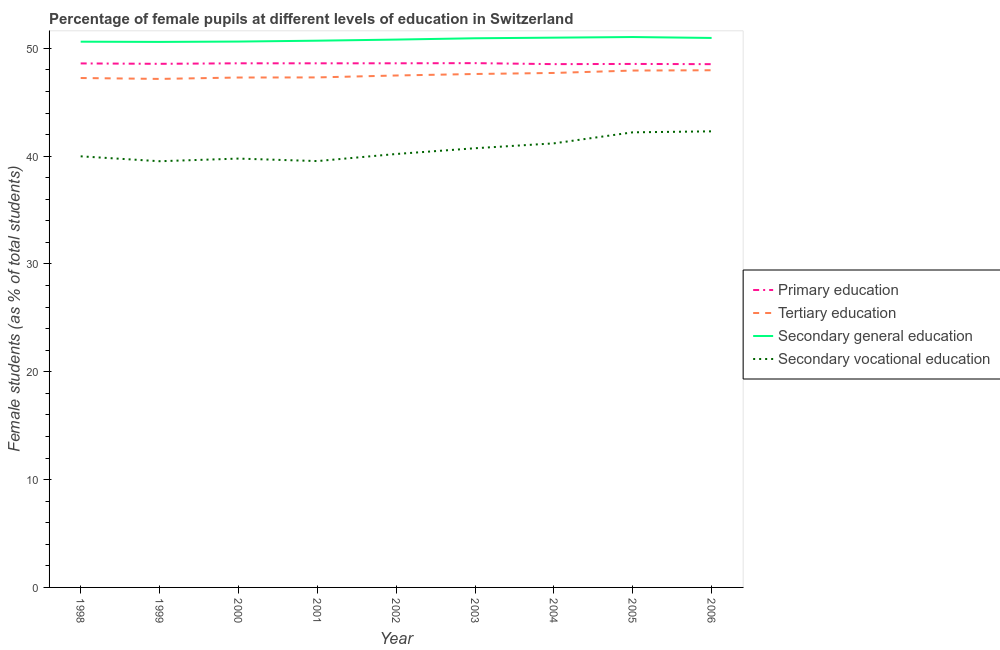What is the percentage of female students in tertiary education in 2006?
Offer a terse response. 47.97. Across all years, what is the maximum percentage of female students in secondary vocational education?
Make the answer very short. 42.31. Across all years, what is the minimum percentage of female students in primary education?
Ensure brevity in your answer.  48.54. In which year was the percentage of female students in tertiary education maximum?
Make the answer very short. 2006. In which year was the percentage of female students in primary education minimum?
Provide a short and direct response. 2006. What is the total percentage of female students in secondary education in the graph?
Keep it short and to the point. 457.34. What is the difference between the percentage of female students in primary education in 1999 and that in 2004?
Provide a short and direct response. 0.03. What is the difference between the percentage of female students in secondary education in 2002 and the percentage of female students in secondary vocational education in 2003?
Provide a short and direct response. 10.08. What is the average percentage of female students in primary education per year?
Offer a terse response. 48.59. In the year 1998, what is the difference between the percentage of female students in secondary education and percentage of female students in tertiary education?
Provide a succinct answer. 3.37. In how many years, is the percentage of female students in secondary vocational education greater than 44 %?
Your answer should be compact. 0. What is the ratio of the percentage of female students in tertiary education in 2001 to that in 2006?
Provide a short and direct response. 0.99. What is the difference between the highest and the second highest percentage of female students in tertiary education?
Keep it short and to the point. 0.03. What is the difference between the highest and the lowest percentage of female students in secondary vocational education?
Provide a short and direct response. 2.77. In how many years, is the percentage of female students in secondary vocational education greater than the average percentage of female students in secondary vocational education taken over all years?
Provide a short and direct response. 4. Is the sum of the percentage of female students in tertiary education in 1998 and 2003 greater than the maximum percentage of female students in secondary vocational education across all years?
Provide a short and direct response. Yes. Is it the case that in every year, the sum of the percentage of female students in primary education and percentage of female students in tertiary education is greater than the sum of percentage of female students in secondary vocational education and percentage of female students in secondary education?
Provide a short and direct response. Yes. Is it the case that in every year, the sum of the percentage of female students in primary education and percentage of female students in tertiary education is greater than the percentage of female students in secondary education?
Provide a short and direct response. Yes. Does the percentage of female students in tertiary education monotonically increase over the years?
Ensure brevity in your answer.  No. Is the percentage of female students in tertiary education strictly less than the percentage of female students in primary education over the years?
Give a very brief answer. Yes. How many lines are there?
Provide a succinct answer. 4. How many years are there in the graph?
Give a very brief answer. 9. Where does the legend appear in the graph?
Your answer should be very brief. Center right. How many legend labels are there?
Your answer should be very brief. 4. What is the title of the graph?
Your answer should be compact. Percentage of female pupils at different levels of education in Switzerland. Does "Japan" appear as one of the legend labels in the graph?
Ensure brevity in your answer.  No. What is the label or title of the Y-axis?
Offer a terse response. Female students (as % of total students). What is the Female students (as % of total students) in Primary education in 1998?
Provide a succinct answer. 48.6. What is the Female students (as % of total students) in Tertiary education in 1998?
Give a very brief answer. 47.25. What is the Female students (as % of total students) of Secondary general education in 1998?
Keep it short and to the point. 50.62. What is the Female students (as % of total students) in Secondary vocational education in 1998?
Provide a succinct answer. 39.99. What is the Female students (as % of total students) of Primary education in 1999?
Offer a terse response. 48.57. What is the Female students (as % of total students) of Tertiary education in 1999?
Offer a very short reply. 47.17. What is the Female students (as % of total students) of Secondary general education in 1999?
Your response must be concise. 50.6. What is the Female students (as % of total students) of Secondary vocational education in 1999?
Provide a short and direct response. 39.53. What is the Female students (as % of total students) of Primary education in 2000?
Give a very brief answer. 48.62. What is the Female students (as % of total students) of Tertiary education in 2000?
Offer a terse response. 47.3. What is the Female students (as % of total students) in Secondary general education in 2000?
Your answer should be compact. 50.63. What is the Female students (as % of total students) in Secondary vocational education in 2000?
Your response must be concise. 39.78. What is the Female students (as % of total students) of Primary education in 2001?
Your response must be concise. 48.61. What is the Female students (as % of total students) of Tertiary education in 2001?
Your answer should be compact. 47.31. What is the Female students (as % of total students) of Secondary general education in 2001?
Make the answer very short. 50.71. What is the Female students (as % of total students) in Secondary vocational education in 2001?
Your response must be concise. 39.55. What is the Female students (as % of total students) in Primary education in 2002?
Provide a short and direct response. 48.62. What is the Female students (as % of total students) in Tertiary education in 2002?
Offer a very short reply. 47.49. What is the Female students (as % of total students) of Secondary general education in 2002?
Make the answer very short. 50.82. What is the Female students (as % of total students) in Secondary vocational education in 2002?
Your answer should be very brief. 40.2. What is the Female students (as % of total students) of Primary education in 2003?
Offer a very short reply. 48.63. What is the Female students (as % of total students) in Tertiary education in 2003?
Your answer should be very brief. 47.62. What is the Female students (as % of total students) of Secondary general education in 2003?
Your answer should be compact. 50.94. What is the Female students (as % of total students) of Secondary vocational education in 2003?
Offer a very short reply. 40.74. What is the Female students (as % of total students) of Primary education in 2004?
Offer a very short reply. 48.54. What is the Female students (as % of total students) in Tertiary education in 2004?
Keep it short and to the point. 47.72. What is the Female students (as % of total students) of Secondary general education in 2004?
Offer a terse response. 50.99. What is the Female students (as % of total students) of Secondary vocational education in 2004?
Make the answer very short. 41.19. What is the Female students (as % of total students) of Primary education in 2005?
Offer a terse response. 48.56. What is the Female students (as % of total students) in Tertiary education in 2005?
Your answer should be very brief. 47.94. What is the Female students (as % of total students) of Secondary general education in 2005?
Make the answer very short. 51.05. What is the Female students (as % of total students) in Secondary vocational education in 2005?
Offer a very short reply. 42.21. What is the Female students (as % of total students) of Primary education in 2006?
Provide a succinct answer. 48.54. What is the Female students (as % of total students) in Tertiary education in 2006?
Your answer should be very brief. 47.97. What is the Female students (as % of total students) in Secondary general education in 2006?
Provide a short and direct response. 50.97. What is the Female students (as % of total students) of Secondary vocational education in 2006?
Provide a short and direct response. 42.31. Across all years, what is the maximum Female students (as % of total students) of Primary education?
Make the answer very short. 48.63. Across all years, what is the maximum Female students (as % of total students) in Tertiary education?
Offer a terse response. 47.97. Across all years, what is the maximum Female students (as % of total students) of Secondary general education?
Offer a very short reply. 51.05. Across all years, what is the maximum Female students (as % of total students) in Secondary vocational education?
Your answer should be very brief. 42.31. Across all years, what is the minimum Female students (as % of total students) in Primary education?
Your answer should be very brief. 48.54. Across all years, what is the minimum Female students (as % of total students) of Tertiary education?
Offer a very short reply. 47.17. Across all years, what is the minimum Female students (as % of total students) in Secondary general education?
Provide a succinct answer. 50.6. Across all years, what is the minimum Female students (as % of total students) in Secondary vocational education?
Your response must be concise. 39.53. What is the total Female students (as % of total students) in Primary education in the graph?
Keep it short and to the point. 437.28. What is the total Female students (as % of total students) of Tertiary education in the graph?
Offer a terse response. 427.77. What is the total Female students (as % of total students) in Secondary general education in the graph?
Offer a terse response. 457.34. What is the total Female students (as % of total students) in Secondary vocational education in the graph?
Your response must be concise. 365.5. What is the difference between the Female students (as % of total students) of Primary education in 1998 and that in 1999?
Make the answer very short. 0.04. What is the difference between the Female students (as % of total students) of Tertiary education in 1998 and that in 1999?
Your answer should be compact. 0.08. What is the difference between the Female students (as % of total students) of Secondary general education in 1998 and that in 1999?
Your response must be concise. 0.02. What is the difference between the Female students (as % of total students) of Secondary vocational education in 1998 and that in 1999?
Your answer should be compact. 0.46. What is the difference between the Female students (as % of total students) in Primary education in 1998 and that in 2000?
Your answer should be very brief. -0.01. What is the difference between the Female students (as % of total students) in Tertiary education in 1998 and that in 2000?
Provide a short and direct response. -0.05. What is the difference between the Female students (as % of total students) in Secondary general education in 1998 and that in 2000?
Offer a terse response. -0.01. What is the difference between the Female students (as % of total students) in Secondary vocational education in 1998 and that in 2000?
Your response must be concise. 0.21. What is the difference between the Female students (as % of total students) in Primary education in 1998 and that in 2001?
Keep it short and to the point. -0.01. What is the difference between the Female students (as % of total students) of Tertiary education in 1998 and that in 2001?
Offer a terse response. -0.06. What is the difference between the Female students (as % of total students) in Secondary general education in 1998 and that in 2001?
Keep it short and to the point. -0.09. What is the difference between the Female students (as % of total students) of Secondary vocational education in 1998 and that in 2001?
Provide a succinct answer. 0.44. What is the difference between the Female students (as % of total students) in Primary education in 1998 and that in 2002?
Provide a short and direct response. -0.01. What is the difference between the Female students (as % of total students) in Tertiary education in 1998 and that in 2002?
Make the answer very short. -0.23. What is the difference between the Female students (as % of total students) of Secondary general education in 1998 and that in 2002?
Your response must be concise. -0.19. What is the difference between the Female students (as % of total students) in Secondary vocational education in 1998 and that in 2002?
Your answer should be compact. -0.22. What is the difference between the Female students (as % of total students) in Primary education in 1998 and that in 2003?
Give a very brief answer. -0.03. What is the difference between the Female students (as % of total students) in Tertiary education in 1998 and that in 2003?
Make the answer very short. -0.37. What is the difference between the Female students (as % of total students) in Secondary general education in 1998 and that in 2003?
Your response must be concise. -0.32. What is the difference between the Female students (as % of total students) of Secondary vocational education in 1998 and that in 2003?
Give a very brief answer. -0.75. What is the difference between the Female students (as % of total students) of Primary education in 1998 and that in 2004?
Provide a succinct answer. 0.07. What is the difference between the Female students (as % of total students) of Tertiary education in 1998 and that in 2004?
Your answer should be compact. -0.47. What is the difference between the Female students (as % of total students) of Secondary general education in 1998 and that in 2004?
Give a very brief answer. -0.37. What is the difference between the Female students (as % of total students) in Secondary vocational education in 1998 and that in 2004?
Offer a very short reply. -1.2. What is the difference between the Female students (as % of total students) in Primary education in 1998 and that in 2005?
Your answer should be compact. 0.05. What is the difference between the Female students (as % of total students) in Tertiary education in 1998 and that in 2005?
Provide a short and direct response. -0.69. What is the difference between the Female students (as % of total students) in Secondary general education in 1998 and that in 2005?
Your answer should be compact. -0.43. What is the difference between the Female students (as % of total students) in Secondary vocational education in 1998 and that in 2005?
Provide a short and direct response. -2.23. What is the difference between the Female students (as % of total students) of Primary education in 1998 and that in 2006?
Make the answer very short. 0.07. What is the difference between the Female students (as % of total students) of Tertiary education in 1998 and that in 2006?
Your answer should be compact. -0.72. What is the difference between the Female students (as % of total students) in Secondary general education in 1998 and that in 2006?
Make the answer very short. -0.35. What is the difference between the Female students (as % of total students) of Secondary vocational education in 1998 and that in 2006?
Offer a terse response. -2.32. What is the difference between the Female students (as % of total students) of Primary education in 1999 and that in 2000?
Your response must be concise. -0.05. What is the difference between the Female students (as % of total students) in Tertiary education in 1999 and that in 2000?
Give a very brief answer. -0.13. What is the difference between the Female students (as % of total students) in Secondary general education in 1999 and that in 2000?
Provide a succinct answer. -0.03. What is the difference between the Female students (as % of total students) of Secondary vocational education in 1999 and that in 2000?
Ensure brevity in your answer.  -0.25. What is the difference between the Female students (as % of total students) of Primary education in 1999 and that in 2001?
Your answer should be very brief. -0.05. What is the difference between the Female students (as % of total students) in Tertiary education in 1999 and that in 2001?
Offer a terse response. -0.14. What is the difference between the Female students (as % of total students) of Secondary general education in 1999 and that in 2001?
Your answer should be very brief. -0.11. What is the difference between the Female students (as % of total students) of Secondary vocational education in 1999 and that in 2001?
Provide a short and direct response. -0.01. What is the difference between the Female students (as % of total students) in Primary education in 1999 and that in 2002?
Give a very brief answer. -0.05. What is the difference between the Female students (as % of total students) of Tertiary education in 1999 and that in 2002?
Your answer should be compact. -0.32. What is the difference between the Female students (as % of total students) of Secondary general education in 1999 and that in 2002?
Provide a succinct answer. -0.22. What is the difference between the Female students (as % of total students) of Secondary vocational education in 1999 and that in 2002?
Provide a succinct answer. -0.67. What is the difference between the Female students (as % of total students) in Primary education in 1999 and that in 2003?
Keep it short and to the point. -0.06. What is the difference between the Female students (as % of total students) of Tertiary education in 1999 and that in 2003?
Offer a terse response. -0.46. What is the difference between the Female students (as % of total students) of Secondary general education in 1999 and that in 2003?
Provide a succinct answer. -0.34. What is the difference between the Female students (as % of total students) of Secondary vocational education in 1999 and that in 2003?
Your answer should be compact. -1.2. What is the difference between the Female students (as % of total students) in Primary education in 1999 and that in 2004?
Your answer should be very brief. 0.03. What is the difference between the Female students (as % of total students) in Tertiary education in 1999 and that in 2004?
Ensure brevity in your answer.  -0.55. What is the difference between the Female students (as % of total students) in Secondary general education in 1999 and that in 2004?
Your answer should be very brief. -0.39. What is the difference between the Female students (as % of total students) in Secondary vocational education in 1999 and that in 2004?
Provide a succinct answer. -1.66. What is the difference between the Female students (as % of total students) in Primary education in 1999 and that in 2005?
Make the answer very short. 0.01. What is the difference between the Female students (as % of total students) in Tertiary education in 1999 and that in 2005?
Offer a terse response. -0.78. What is the difference between the Female students (as % of total students) in Secondary general education in 1999 and that in 2005?
Offer a terse response. -0.45. What is the difference between the Female students (as % of total students) of Secondary vocational education in 1999 and that in 2005?
Offer a terse response. -2.68. What is the difference between the Female students (as % of total students) in Primary education in 1999 and that in 2006?
Your answer should be very brief. 0.03. What is the difference between the Female students (as % of total students) in Tertiary education in 1999 and that in 2006?
Your response must be concise. -0.8. What is the difference between the Female students (as % of total students) in Secondary general education in 1999 and that in 2006?
Your answer should be very brief. -0.37. What is the difference between the Female students (as % of total students) of Secondary vocational education in 1999 and that in 2006?
Provide a succinct answer. -2.77. What is the difference between the Female students (as % of total students) in Primary education in 2000 and that in 2001?
Your answer should be very brief. 0. What is the difference between the Female students (as % of total students) of Tertiary education in 2000 and that in 2001?
Make the answer very short. -0.01. What is the difference between the Female students (as % of total students) of Secondary general education in 2000 and that in 2001?
Give a very brief answer. -0.08. What is the difference between the Female students (as % of total students) of Secondary vocational education in 2000 and that in 2001?
Provide a short and direct response. 0.23. What is the difference between the Female students (as % of total students) in Primary education in 2000 and that in 2002?
Your answer should be very brief. -0. What is the difference between the Female students (as % of total students) of Tertiary education in 2000 and that in 2002?
Your answer should be compact. -0.19. What is the difference between the Female students (as % of total students) of Secondary general education in 2000 and that in 2002?
Provide a succinct answer. -0.18. What is the difference between the Female students (as % of total students) of Secondary vocational education in 2000 and that in 2002?
Offer a very short reply. -0.43. What is the difference between the Female students (as % of total students) in Primary education in 2000 and that in 2003?
Make the answer very short. -0.02. What is the difference between the Female students (as % of total students) in Tertiary education in 2000 and that in 2003?
Offer a very short reply. -0.33. What is the difference between the Female students (as % of total students) of Secondary general education in 2000 and that in 2003?
Give a very brief answer. -0.3. What is the difference between the Female students (as % of total students) of Secondary vocational education in 2000 and that in 2003?
Your response must be concise. -0.96. What is the difference between the Female students (as % of total students) in Primary education in 2000 and that in 2004?
Make the answer very short. 0.08. What is the difference between the Female students (as % of total students) in Tertiary education in 2000 and that in 2004?
Offer a terse response. -0.42. What is the difference between the Female students (as % of total students) in Secondary general education in 2000 and that in 2004?
Make the answer very short. -0.36. What is the difference between the Female students (as % of total students) of Secondary vocational education in 2000 and that in 2004?
Keep it short and to the point. -1.41. What is the difference between the Female students (as % of total students) of Primary education in 2000 and that in 2005?
Your response must be concise. 0.06. What is the difference between the Female students (as % of total students) of Tertiary education in 2000 and that in 2005?
Provide a succinct answer. -0.65. What is the difference between the Female students (as % of total students) of Secondary general education in 2000 and that in 2005?
Offer a terse response. -0.42. What is the difference between the Female students (as % of total students) of Secondary vocational education in 2000 and that in 2005?
Your answer should be compact. -2.44. What is the difference between the Female students (as % of total students) of Primary education in 2000 and that in 2006?
Your answer should be compact. 0.08. What is the difference between the Female students (as % of total students) in Tertiary education in 2000 and that in 2006?
Keep it short and to the point. -0.67. What is the difference between the Female students (as % of total students) of Secondary general education in 2000 and that in 2006?
Your response must be concise. -0.33. What is the difference between the Female students (as % of total students) in Secondary vocational education in 2000 and that in 2006?
Make the answer very short. -2.53. What is the difference between the Female students (as % of total students) of Primary education in 2001 and that in 2002?
Your response must be concise. -0. What is the difference between the Female students (as % of total students) of Tertiary education in 2001 and that in 2002?
Keep it short and to the point. -0.18. What is the difference between the Female students (as % of total students) of Secondary general education in 2001 and that in 2002?
Offer a very short reply. -0.1. What is the difference between the Female students (as % of total students) in Secondary vocational education in 2001 and that in 2002?
Keep it short and to the point. -0.66. What is the difference between the Female students (as % of total students) of Primary education in 2001 and that in 2003?
Your answer should be compact. -0.02. What is the difference between the Female students (as % of total students) in Tertiary education in 2001 and that in 2003?
Provide a succinct answer. -0.32. What is the difference between the Female students (as % of total students) of Secondary general education in 2001 and that in 2003?
Provide a succinct answer. -0.22. What is the difference between the Female students (as % of total students) in Secondary vocational education in 2001 and that in 2003?
Your answer should be compact. -1.19. What is the difference between the Female students (as % of total students) in Primary education in 2001 and that in 2004?
Give a very brief answer. 0.08. What is the difference between the Female students (as % of total students) in Tertiary education in 2001 and that in 2004?
Offer a very short reply. -0.41. What is the difference between the Female students (as % of total students) of Secondary general education in 2001 and that in 2004?
Provide a short and direct response. -0.28. What is the difference between the Female students (as % of total students) of Secondary vocational education in 2001 and that in 2004?
Your answer should be very brief. -1.64. What is the difference between the Female students (as % of total students) in Primary education in 2001 and that in 2005?
Your response must be concise. 0.06. What is the difference between the Female students (as % of total students) of Tertiary education in 2001 and that in 2005?
Provide a short and direct response. -0.64. What is the difference between the Female students (as % of total students) of Secondary general education in 2001 and that in 2005?
Give a very brief answer. -0.34. What is the difference between the Female students (as % of total students) in Secondary vocational education in 2001 and that in 2005?
Offer a terse response. -2.67. What is the difference between the Female students (as % of total students) of Primary education in 2001 and that in 2006?
Offer a very short reply. 0.08. What is the difference between the Female students (as % of total students) in Tertiary education in 2001 and that in 2006?
Provide a succinct answer. -0.66. What is the difference between the Female students (as % of total students) of Secondary general education in 2001 and that in 2006?
Provide a short and direct response. -0.25. What is the difference between the Female students (as % of total students) of Secondary vocational education in 2001 and that in 2006?
Your response must be concise. -2.76. What is the difference between the Female students (as % of total students) in Primary education in 2002 and that in 2003?
Your answer should be very brief. -0.01. What is the difference between the Female students (as % of total students) in Tertiary education in 2002 and that in 2003?
Offer a very short reply. -0.14. What is the difference between the Female students (as % of total students) in Secondary general education in 2002 and that in 2003?
Give a very brief answer. -0.12. What is the difference between the Female students (as % of total students) of Secondary vocational education in 2002 and that in 2003?
Provide a short and direct response. -0.53. What is the difference between the Female students (as % of total students) of Primary education in 2002 and that in 2004?
Your answer should be compact. 0.08. What is the difference between the Female students (as % of total students) in Tertiary education in 2002 and that in 2004?
Your response must be concise. -0.24. What is the difference between the Female students (as % of total students) of Secondary general education in 2002 and that in 2004?
Provide a short and direct response. -0.18. What is the difference between the Female students (as % of total students) in Secondary vocational education in 2002 and that in 2004?
Provide a short and direct response. -0.99. What is the difference between the Female students (as % of total students) of Primary education in 2002 and that in 2005?
Ensure brevity in your answer.  0.06. What is the difference between the Female students (as % of total students) of Tertiary education in 2002 and that in 2005?
Your answer should be compact. -0.46. What is the difference between the Female students (as % of total students) of Secondary general education in 2002 and that in 2005?
Offer a terse response. -0.24. What is the difference between the Female students (as % of total students) in Secondary vocational education in 2002 and that in 2005?
Ensure brevity in your answer.  -2.01. What is the difference between the Female students (as % of total students) of Primary education in 2002 and that in 2006?
Keep it short and to the point. 0.08. What is the difference between the Female students (as % of total students) in Tertiary education in 2002 and that in 2006?
Keep it short and to the point. -0.49. What is the difference between the Female students (as % of total students) in Secondary general education in 2002 and that in 2006?
Make the answer very short. -0.15. What is the difference between the Female students (as % of total students) in Secondary vocational education in 2002 and that in 2006?
Ensure brevity in your answer.  -2.1. What is the difference between the Female students (as % of total students) of Primary education in 2003 and that in 2004?
Your response must be concise. 0.09. What is the difference between the Female students (as % of total students) in Tertiary education in 2003 and that in 2004?
Your answer should be compact. -0.1. What is the difference between the Female students (as % of total students) in Secondary general education in 2003 and that in 2004?
Give a very brief answer. -0.06. What is the difference between the Female students (as % of total students) in Secondary vocational education in 2003 and that in 2004?
Your response must be concise. -0.45. What is the difference between the Female students (as % of total students) in Primary education in 2003 and that in 2005?
Your answer should be very brief. 0.07. What is the difference between the Female students (as % of total students) in Tertiary education in 2003 and that in 2005?
Your answer should be compact. -0.32. What is the difference between the Female students (as % of total students) of Secondary general education in 2003 and that in 2005?
Offer a terse response. -0.11. What is the difference between the Female students (as % of total students) of Secondary vocational education in 2003 and that in 2005?
Your answer should be very brief. -1.48. What is the difference between the Female students (as % of total students) of Primary education in 2003 and that in 2006?
Ensure brevity in your answer.  0.09. What is the difference between the Female students (as % of total students) of Tertiary education in 2003 and that in 2006?
Give a very brief answer. -0.35. What is the difference between the Female students (as % of total students) in Secondary general education in 2003 and that in 2006?
Offer a terse response. -0.03. What is the difference between the Female students (as % of total students) of Secondary vocational education in 2003 and that in 2006?
Offer a very short reply. -1.57. What is the difference between the Female students (as % of total students) in Primary education in 2004 and that in 2005?
Ensure brevity in your answer.  -0.02. What is the difference between the Female students (as % of total students) in Tertiary education in 2004 and that in 2005?
Offer a very short reply. -0.22. What is the difference between the Female students (as % of total students) of Secondary general education in 2004 and that in 2005?
Make the answer very short. -0.06. What is the difference between the Female students (as % of total students) of Secondary vocational education in 2004 and that in 2005?
Your answer should be very brief. -1.02. What is the difference between the Female students (as % of total students) in Primary education in 2004 and that in 2006?
Provide a succinct answer. 0. What is the difference between the Female students (as % of total students) in Tertiary education in 2004 and that in 2006?
Your response must be concise. -0.25. What is the difference between the Female students (as % of total students) in Secondary general education in 2004 and that in 2006?
Provide a succinct answer. 0.03. What is the difference between the Female students (as % of total students) of Secondary vocational education in 2004 and that in 2006?
Your answer should be compact. -1.11. What is the difference between the Female students (as % of total students) of Primary education in 2005 and that in 2006?
Give a very brief answer. 0.02. What is the difference between the Female students (as % of total students) in Tertiary education in 2005 and that in 2006?
Ensure brevity in your answer.  -0.03. What is the difference between the Female students (as % of total students) in Secondary general education in 2005 and that in 2006?
Keep it short and to the point. 0.09. What is the difference between the Female students (as % of total students) in Secondary vocational education in 2005 and that in 2006?
Make the answer very short. -0.09. What is the difference between the Female students (as % of total students) of Primary education in 1998 and the Female students (as % of total students) of Tertiary education in 1999?
Your answer should be compact. 1.44. What is the difference between the Female students (as % of total students) of Primary education in 1998 and the Female students (as % of total students) of Secondary general education in 1999?
Offer a terse response. -2. What is the difference between the Female students (as % of total students) in Primary education in 1998 and the Female students (as % of total students) in Secondary vocational education in 1999?
Your answer should be very brief. 9.07. What is the difference between the Female students (as % of total students) in Tertiary education in 1998 and the Female students (as % of total students) in Secondary general education in 1999?
Your answer should be compact. -3.35. What is the difference between the Female students (as % of total students) of Tertiary education in 1998 and the Female students (as % of total students) of Secondary vocational education in 1999?
Offer a very short reply. 7.72. What is the difference between the Female students (as % of total students) of Secondary general education in 1998 and the Female students (as % of total students) of Secondary vocational education in 1999?
Your answer should be very brief. 11.09. What is the difference between the Female students (as % of total students) of Primary education in 1998 and the Female students (as % of total students) of Tertiary education in 2000?
Offer a very short reply. 1.31. What is the difference between the Female students (as % of total students) of Primary education in 1998 and the Female students (as % of total students) of Secondary general education in 2000?
Keep it short and to the point. -2.03. What is the difference between the Female students (as % of total students) of Primary education in 1998 and the Female students (as % of total students) of Secondary vocational education in 2000?
Provide a short and direct response. 8.83. What is the difference between the Female students (as % of total students) of Tertiary education in 1998 and the Female students (as % of total students) of Secondary general education in 2000?
Offer a very short reply. -3.38. What is the difference between the Female students (as % of total students) of Tertiary education in 1998 and the Female students (as % of total students) of Secondary vocational education in 2000?
Make the answer very short. 7.47. What is the difference between the Female students (as % of total students) of Secondary general education in 1998 and the Female students (as % of total students) of Secondary vocational education in 2000?
Offer a very short reply. 10.84. What is the difference between the Female students (as % of total students) in Primary education in 1998 and the Female students (as % of total students) in Tertiary education in 2001?
Give a very brief answer. 1.3. What is the difference between the Female students (as % of total students) in Primary education in 1998 and the Female students (as % of total students) in Secondary general education in 2001?
Keep it short and to the point. -2.11. What is the difference between the Female students (as % of total students) of Primary education in 1998 and the Female students (as % of total students) of Secondary vocational education in 2001?
Your response must be concise. 9.06. What is the difference between the Female students (as % of total students) in Tertiary education in 1998 and the Female students (as % of total students) in Secondary general education in 2001?
Provide a short and direct response. -3.46. What is the difference between the Female students (as % of total students) of Tertiary education in 1998 and the Female students (as % of total students) of Secondary vocational education in 2001?
Offer a very short reply. 7.71. What is the difference between the Female students (as % of total students) in Secondary general education in 1998 and the Female students (as % of total students) in Secondary vocational education in 2001?
Provide a succinct answer. 11.07. What is the difference between the Female students (as % of total students) of Primary education in 1998 and the Female students (as % of total students) of Tertiary education in 2002?
Provide a succinct answer. 1.12. What is the difference between the Female students (as % of total students) in Primary education in 1998 and the Female students (as % of total students) in Secondary general education in 2002?
Offer a terse response. -2.21. What is the difference between the Female students (as % of total students) in Primary education in 1998 and the Female students (as % of total students) in Secondary vocational education in 2002?
Provide a short and direct response. 8.4. What is the difference between the Female students (as % of total students) of Tertiary education in 1998 and the Female students (as % of total students) of Secondary general education in 2002?
Provide a short and direct response. -3.56. What is the difference between the Female students (as % of total students) in Tertiary education in 1998 and the Female students (as % of total students) in Secondary vocational education in 2002?
Offer a terse response. 7.05. What is the difference between the Female students (as % of total students) of Secondary general education in 1998 and the Female students (as % of total students) of Secondary vocational education in 2002?
Provide a succinct answer. 10.42. What is the difference between the Female students (as % of total students) in Primary education in 1998 and the Female students (as % of total students) in Tertiary education in 2003?
Your response must be concise. 0.98. What is the difference between the Female students (as % of total students) in Primary education in 1998 and the Female students (as % of total students) in Secondary general education in 2003?
Your response must be concise. -2.33. What is the difference between the Female students (as % of total students) in Primary education in 1998 and the Female students (as % of total students) in Secondary vocational education in 2003?
Ensure brevity in your answer.  7.87. What is the difference between the Female students (as % of total students) in Tertiary education in 1998 and the Female students (as % of total students) in Secondary general education in 2003?
Ensure brevity in your answer.  -3.69. What is the difference between the Female students (as % of total students) of Tertiary education in 1998 and the Female students (as % of total students) of Secondary vocational education in 2003?
Make the answer very short. 6.51. What is the difference between the Female students (as % of total students) of Secondary general education in 1998 and the Female students (as % of total students) of Secondary vocational education in 2003?
Make the answer very short. 9.88. What is the difference between the Female students (as % of total students) in Primary education in 1998 and the Female students (as % of total students) in Tertiary education in 2004?
Provide a succinct answer. 0.88. What is the difference between the Female students (as % of total students) of Primary education in 1998 and the Female students (as % of total students) of Secondary general education in 2004?
Your response must be concise. -2.39. What is the difference between the Female students (as % of total students) of Primary education in 1998 and the Female students (as % of total students) of Secondary vocational education in 2004?
Offer a terse response. 7.41. What is the difference between the Female students (as % of total students) in Tertiary education in 1998 and the Female students (as % of total students) in Secondary general education in 2004?
Your answer should be very brief. -3.74. What is the difference between the Female students (as % of total students) of Tertiary education in 1998 and the Female students (as % of total students) of Secondary vocational education in 2004?
Make the answer very short. 6.06. What is the difference between the Female students (as % of total students) in Secondary general education in 1998 and the Female students (as % of total students) in Secondary vocational education in 2004?
Provide a succinct answer. 9.43. What is the difference between the Female students (as % of total students) in Primary education in 1998 and the Female students (as % of total students) in Tertiary education in 2005?
Offer a terse response. 0.66. What is the difference between the Female students (as % of total students) in Primary education in 1998 and the Female students (as % of total students) in Secondary general education in 2005?
Ensure brevity in your answer.  -2.45. What is the difference between the Female students (as % of total students) of Primary education in 1998 and the Female students (as % of total students) of Secondary vocational education in 2005?
Give a very brief answer. 6.39. What is the difference between the Female students (as % of total students) in Tertiary education in 1998 and the Female students (as % of total students) in Secondary general education in 2005?
Your response must be concise. -3.8. What is the difference between the Female students (as % of total students) of Tertiary education in 1998 and the Female students (as % of total students) of Secondary vocational education in 2005?
Make the answer very short. 5.04. What is the difference between the Female students (as % of total students) of Secondary general education in 1998 and the Female students (as % of total students) of Secondary vocational education in 2005?
Offer a terse response. 8.41. What is the difference between the Female students (as % of total students) of Primary education in 1998 and the Female students (as % of total students) of Tertiary education in 2006?
Your response must be concise. 0.63. What is the difference between the Female students (as % of total students) of Primary education in 1998 and the Female students (as % of total students) of Secondary general education in 2006?
Make the answer very short. -2.36. What is the difference between the Female students (as % of total students) in Primary education in 1998 and the Female students (as % of total students) in Secondary vocational education in 2006?
Offer a terse response. 6.3. What is the difference between the Female students (as % of total students) of Tertiary education in 1998 and the Female students (as % of total students) of Secondary general education in 2006?
Your answer should be very brief. -3.72. What is the difference between the Female students (as % of total students) in Tertiary education in 1998 and the Female students (as % of total students) in Secondary vocational education in 2006?
Ensure brevity in your answer.  4.95. What is the difference between the Female students (as % of total students) of Secondary general education in 1998 and the Female students (as % of total students) of Secondary vocational education in 2006?
Ensure brevity in your answer.  8.32. What is the difference between the Female students (as % of total students) of Primary education in 1999 and the Female students (as % of total students) of Tertiary education in 2000?
Provide a succinct answer. 1.27. What is the difference between the Female students (as % of total students) of Primary education in 1999 and the Female students (as % of total students) of Secondary general education in 2000?
Your response must be concise. -2.06. What is the difference between the Female students (as % of total students) of Primary education in 1999 and the Female students (as % of total students) of Secondary vocational education in 2000?
Offer a terse response. 8.79. What is the difference between the Female students (as % of total students) in Tertiary education in 1999 and the Female students (as % of total students) in Secondary general education in 2000?
Your answer should be compact. -3.47. What is the difference between the Female students (as % of total students) of Tertiary education in 1999 and the Female students (as % of total students) of Secondary vocational education in 2000?
Ensure brevity in your answer.  7.39. What is the difference between the Female students (as % of total students) in Secondary general education in 1999 and the Female students (as % of total students) in Secondary vocational education in 2000?
Offer a terse response. 10.82. What is the difference between the Female students (as % of total students) of Primary education in 1999 and the Female students (as % of total students) of Tertiary education in 2001?
Give a very brief answer. 1.26. What is the difference between the Female students (as % of total students) in Primary education in 1999 and the Female students (as % of total students) in Secondary general education in 2001?
Offer a terse response. -2.15. What is the difference between the Female students (as % of total students) in Primary education in 1999 and the Female students (as % of total students) in Secondary vocational education in 2001?
Your answer should be compact. 9.02. What is the difference between the Female students (as % of total students) of Tertiary education in 1999 and the Female students (as % of total students) of Secondary general education in 2001?
Your answer should be very brief. -3.55. What is the difference between the Female students (as % of total students) of Tertiary education in 1999 and the Female students (as % of total students) of Secondary vocational education in 2001?
Provide a succinct answer. 7.62. What is the difference between the Female students (as % of total students) of Secondary general education in 1999 and the Female students (as % of total students) of Secondary vocational education in 2001?
Provide a succinct answer. 11.05. What is the difference between the Female students (as % of total students) in Primary education in 1999 and the Female students (as % of total students) in Tertiary education in 2002?
Give a very brief answer. 1.08. What is the difference between the Female students (as % of total students) in Primary education in 1999 and the Female students (as % of total students) in Secondary general education in 2002?
Keep it short and to the point. -2.25. What is the difference between the Female students (as % of total students) of Primary education in 1999 and the Female students (as % of total students) of Secondary vocational education in 2002?
Provide a short and direct response. 8.36. What is the difference between the Female students (as % of total students) of Tertiary education in 1999 and the Female students (as % of total students) of Secondary general education in 2002?
Your response must be concise. -3.65. What is the difference between the Female students (as % of total students) of Tertiary education in 1999 and the Female students (as % of total students) of Secondary vocational education in 2002?
Your response must be concise. 6.96. What is the difference between the Female students (as % of total students) of Secondary general education in 1999 and the Female students (as % of total students) of Secondary vocational education in 2002?
Ensure brevity in your answer.  10.4. What is the difference between the Female students (as % of total students) of Primary education in 1999 and the Female students (as % of total students) of Tertiary education in 2003?
Your answer should be very brief. 0.94. What is the difference between the Female students (as % of total students) in Primary education in 1999 and the Female students (as % of total students) in Secondary general education in 2003?
Give a very brief answer. -2.37. What is the difference between the Female students (as % of total students) in Primary education in 1999 and the Female students (as % of total students) in Secondary vocational education in 2003?
Your answer should be compact. 7.83. What is the difference between the Female students (as % of total students) in Tertiary education in 1999 and the Female students (as % of total students) in Secondary general education in 2003?
Your answer should be compact. -3.77. What is the difference between the Female students (as % of total students) of Tertiary education in 1999 and the Female students (as % of total students) of Secondary vocational education in 2003?
Ensure brevity in your answer.  6.43. What is the difference between the Female students (as % of total students) of Secondary general education in 1999 and the Female students (as % of total students) of Secondary vocational education in 2003?
Your answer should be very brief. 9.86. What is the difference between the Female students (as % of total students) in Primary education in 1999 and the Female students (as % of total students) in Tertiary education in 2004?
Give a very brief answer. 0.85. What is the difference between the Female students (as % of total students) in Primary education in 1999 and the Female students (as % of total students) in Secondary general education in 2004?
Your answer should be very brief. -2.43. What is the difference between the Female students (as % of total students) in Primary education in 1999 and the Female students (as % of total students) in Secondary vocational education in 2004?
Make the answer very short. 7.38. What is the difference between the Female students (as % of total students) in Tertiary education in 1999 and the Female students (as % of total students) in Secondary general education in 2004?
Provide a short and direct response. -3.83. What is the difference between the Female students (as % of total students) in Tertiary education in 1999 and the Female students (as % of total students) in Secondary vocational education in 2004?
Your answer should be compact. 5.98. What is the difference between the Female students (as % of total students) in Secondary general education in 1999 and the Female students (as % of total students) in Secondary vocational education in 2004?
Ensure brevity in your answer.  9.41. What is the difference between the Female students (as % of total students) in Primary education in 1999 and the Female students (as % of total students) in Tertiary education in 2005?
Offer a very short reply. 0.62. What is the difference between the Female students (as % of total students) of Primary education in 1999 and the Female students (as % of total students) of Secondary general education in 2005?
Your response must be concise. -2.48. What is the difference between the Female students (as % of total students) in Primary education in 1999 and the Female students (as % of total students) in Secondary vocational education in 2005?
Offer a terse response. 6.35. What is the difference between the Female students (as % of total students) in Tertiary education in 1999 and the Female students (as % of total students) in Secondary general education in 2005?
Provide a short and direct response. -3.88. What is the difference between the Female students (as % of total students) of Tertiary education in 1999 and the Female students (as % of total students) of Secondary vocational education in 2005?
Your answer should be very brief. 4.95. What is the difference between the Female students (as % of total students) of Secondary general education in 1999 and the Female students (as % of total students) of Secondary vocational education in 2005?
Provide a succinct answer. 8.39. What is the difference between the Female students (as % of total students) of Primary education in 1999 and the Female students (as % of total students) of Tertiary education in 2006?
Ensure brevity in your answer.  0.6. What is the difference between the Female students (as % of total students) of Primary education in 1999 and the Female students (as % of total students) of Secondary general education in 2006?
Keep it short and to the point. -2.4. What is the difference between the Female students (as % of total students) of Primary education in 1999 and the Female students (as % of total students) of Secondary vocational education in 2006?
Give a very brief answer. 6.26. What is the difference between the Female students (as % of total students) of Tertiary education in 1999 and the Female students (as % of total students) of Secondary general education in 2006?
Provide a succinct answer. -3.8. What is the difference between the Female students (as % of total students) in Tertiary education in 1999 and the Female students (as % of total students) in Secondary vocational education in 2006?
Make the answer very short. 4.86. What is the difference between the Female students (as % of total students) in Secondary general education in 1999 and the Female students (as % of total students) in Secondary vocational education in 2006?
Your answer should be compact. 8.3. What is the difference between the Female students (as % of total students) of Primary education in 2000 and the Female students (as % of total students) of Tertiary education in 2001?
Make the answer very short. 1.31. What is the difference between the Female students (as % of total students) in Primary education in 2000 and the Female students (as % of total students) in Secondary general education in 2001?
Provide a short and direct response. -2.1. What is the difference between the Female students (as % of total students) in Primary education in 2000 and the Female students (as % of total students) in Secondary vocational education in 2001?
Offer a very short reply. 9.07. What is the difference between the Female students (as % of total students) in Tertiary education in 2000 and the Female students (as % of total students) in Secondary general education in 2001?
Keep it short and to the point. -3.42. What is the difference between the Female students (as % of total students) in Tertiary education in 2000 and the Female students (as % of total students) in Secondary vocational education in 2001?
Provide a succinct answer. 7.75. What is the difference between the Female students (as % of total students) of Secondary general education in 2000 and the Female students (as % of total students) of Secondary vocational education in 2001?
Your response must be concise. 11.09. What is the difference between the Female students (as % of total students) in Primary education in 2000 and the Female students (as % of total students) in Tertiary education in 2002?
Offer a very short reply. 1.13. What is the difference between the Female students (as % of total students) in Primary education in 2000 and the Female students (as % of total students) in Secondary vocational education in 2002?
Provide a short and direct response. 8.41. What is the difference between the Female students (as % of total students) of Tertiary education in 2000 and the Female students (as % of total students) of Secondary general education in 2002?
Provide a succinct answer. -3.52. What is the difference between the Female students (as % of total students) of Tertiary education in 2000 and the Female students (as % of total students) of Secondary vocational education in 2002?
Make the answer very short. 7.09. What is the difference between the Female students (as % of total students) of Secondary general education in 2000 and the Female students (as % of total students) of Secondary vocational education in 2002?
Give a very brief answer. 10.43. What is the difference between the Female students (as % of total students) of Primary education in 2000 and the Female students (as % of total students) of Tertiary education in 2003?
Your answer should be compact. 0.99. What is the difference between the Female students (as % of total students) of Primary education in 2000 and the Female students (as % of total students) of Secondary general education in 2003?
Ensure brevity in your answer.  -2.32. What is the difference between the Female students (as % of total students) in Primary education in 2000 and the Female students (as % of total students) in Secondary vocational education in 2003?
Provide a succinct answer. 7.88. What is the difference between the Female students (as % of total students) in Tertiary education in 2000 and the Female students (as % of total students) in Secondary general education in 2003?
Ensure brevity in your answer.  -3.64. What is the difference between the Female students (as % of total students) in Tertiary education in 2000 and the Female students (as % of total students) in Secondary vocational education in 2003?
Keep it short and to the point. 6.56. What is the difference between the Female students (as % of total students) of Secondary general education in 2000 and the Female students (as % of total students) of Secondary vocational education in 2003?
Offer a very short reply. 9.9. What is the difference between the Female students (as % of total students) of Primary education in 2000 and the Female students (as % of total students) of Tertiary education in 2004?
Your answer should be very brief. 0.9. What is the difference between the Female students (as % of total students) of Primary education in 2000 and the Female students (as % of total students) of Secondary general education in 2004?
Provide a short and direct response. -2.38. What is the difference between the Female students (as % of total students) in Primary education in 2000 and the Female students (as % of total students) in Secondary vocational education in 2004?
Make the answer very short. 7.42. What is the difference between the Female students (as % of total students) of Tertiary education in 2000 and the Female students (as % of total students) of Secondary general education in 2004?
Ensure brevity in your answer.  -3.7. What is the difference between the Female students (as % of total students) of Tertiary education in 2000 and the Female students (as % of total students) of Secondary vocational education in 2004?
Make the answer very short. 6.11. What is the difference between the Female students (as % of total students) of Secondary general education in 2000 and the Female students (as % of total students) of Secondary vocational education in 2004?
Provide a short and direct response. 9.44. What is the difference between the Female students (as % of total students) in Primary education in 2000 and the Female students (as % of total students) in Tertiary education in 2005?
Your response must be concise. 0.67. What is the difference between the Female students (as % of total students) of Primary education in 2000 and the Female students (as % of total students) of Secondary general education in 2005?
Your answer should be very brief. -2.44. What is the difference between the Female students (as % of total students) of Primary education in 2000 and the Female students (as % of total students) of Secondary vocational education in 2005?
Give a very brief answer. 6.4. What is the difference between the Female students (as % of total students) of Tertiary education in 2000 and the Female students (as % of total students) of Secondary general education in 2005?
Your answer should be compact. -3.75. What is the difference between the Female students (as % of total students) of Tertiary education in 2000 and the Female students (as % of total students) of Secondary vocational education in 2005?
Provide a succinct answer. 5.08. What is the difference between the Female students (as % of total students) of Secondary general education in 2000 and the Female students (as % of total students) of Secondary vocational education in 2005?
Provide a succinct answer. 8.42. What is the difference between the Female students (as % of total students) in Primary education in 2000 and the Female students (as % of total students) in Tertiary education in 2006?
Keep it short and to the point. 0.64. What is the difference between the Female students (as % of total students) in Primary education in 2000 and the Female students (as % of total students) in Secondary general education in 2006?
Your response must be concise. -2.35. What is the difference between the Female students (as % of total students) in Primary education in 2000 and the Female students (as % of total students) in Secondary vocational education in 2006?
Your answer should be very brief. 6.31. What is the difference between the Female students (as % of total students) in Tertiary education in 2000 and the Female students (as % of total students) in Secondary general education in 2006?
Keep it short and to the point. -3.67. What is the difference between the Female students (as % of total students) of Tertiary education in 2000 and the Female students (as % of total students) of Secondary vocational education in 2006?
Offer a very short reply. 4.99. What is the difference between the Female students (as % of total students) in Secondary general education in 2000 and the Female students (as % of total students) in Secondary vocational education in 2006?
Make the answer very short. 8.33. What is the difference between the Female students (as % of total students) in Primary education in 2001 and the Female students (as % of total students) in Tertiary education in 2002?
Ensure brevity in your answer.  1.13. What is the difference between the Female students (as % of total students) of Primary education in 2001 and the Female students (as % of total students) of Secondary general education in 2002?
Provide a succinct answer. -2.2. What is the difference between the Female students (as % of total students) of Primary education in 2001 and the Female students (as % of total students) of Secondary vocational education in 2002?
Your answer should be compact. 8.41. What is the difference between the Female students (as % of total students) of Tertiary education in 2001 and the Female students (as % of total students) of Secondary general education in 2002?
Ensure brevity in your answer.  -3.51. What is the difference between the Female students (as % of total students) of Tertiary education in 2001 and the Female students (as % of total students) of Secondary vocational education in 2002?
Keep it short and to the point. 7.1. What is the difference between the Female students (as % of total students) in Secondary general education in 2001 and the Female students (as % of total students) in Secondary vocational education in 2002?
Your answer should be very brief. 10.51. What is the difference between the Female students (as % of total students) of Primary education in 2001 and the Female students (as % of total students) of Tertiary education in 2003?
Keep it short and to the point. 0.99. What is the difference between the Female students (as % of total students) of Primary education in 2001 and the Female students (as % of total students) of Secondary general education in 2003?
Your answer should be very brief. -2.32. What is the difference between the Female students (as % of total students) of Primary education in 2001 and the Female students (as % of total students) of Secondary vocational education in 2003?
Make the answer very short. 7.88. What is the difference between the Female students (as % of total students) in Tertiary education in 2001 and the Female students (as % of total students) in Secondary general education in 2003?
Your response must be concise. -3.63. What is the difference between the Female students (as % of total students) in Tertiary education in 2001 and the Female students (as % of total students) in Secondary vocational education in 2003?
Provide a succinct answer. 6.57. What is the difference between the Female students (as % of total students) in Secondary general education in 2001 and the Female students (as % of total students) in Secondary vocational education in 2003?
Offer a very short reply. 9.98. What is the difference between the Female students (as % of total students) of Primary education in 2001 and the Female students (as % of total students) of Tertiary education in 2004?
Your answer should be very brief. 0.89. What is the difference between the Female students (as % of total students) in Primary education in 2001 and the Female students (as % of total students) in Secondary general education in 2004?
Keep it short and to the point. -2.38. What is the difference between the Female students (as % of total students) in Primary education in 2001 and the Female students (as % of total students) in Secondary vocational education in 2004?
Give a very brief answer. 7.42. What is the difference between the Female students (as % of total students) of Tertiary education in 2001 and the Female students (as % of total students) of Secondary general education in 2004?
Keep it short and to the point. -3.69. What is the difference between the Female students (as % of total students) of Tertiary education in 2001 and the Female students (as % of total students) of Secondary vocational education in 2004?
Your answer should be very brief. 6.12. What is the difference between the Female students (as % of total students) in Secondary general education in 2001 and the Female students (as % of total students) in Secondary vocational education in 2004?
Give a very brief answer. 9.52. What is the difference between the Female students (as % of total students) in Primary education in 2001 and the Female students (as % of total students) in Tertiary education in 2005?
Offer a very short reply. 0.67. What is the difference between the Female students (as % of total students) in Primary education in 2001 and the Female students (as % of total students) in Secondary general education in 2005?
Offer a terse response. -2.44. What is the difference between the Female students (as % of total students) in Primary education in 2001 and the Female students (as % of total students) in Secondary vocational education in 2005?
Ensure brevity in your answer.  6.4. What is the difference between the Female students (as % of total students) of Tertiary education in 2001 and the Female students (as % of total students) of Secondary general education in 2005?
Keep it short and to the point. -3.75. What is the difference between the Female students (as % of total students) in Tertiary education in 2001 and the Female students (as % of total students) in Secondary vocational education in 2005?
Your answer should be compact. 5.09. What is the difference between the Female students (as % of total students) in Secondary general education in 2001 and the Female students (as % of total students) in Secondary vocational education in 2005?
Your response must be concise. 8.5. What is the difference between the Female students (as % of total students) in Primary education in 2001 and the Female students (as % of total students) in Tertiary education in 2006?
Offer a very short reply. 0.64. What is the difference between the Female students (as % of total students) in Primary education in 2001 and the Female students (as % of total students) in Secondary general education in 2006?
Your answer should be very brief. -2.35. What is the difference between the Female students (as % of total students) in Primary education in 2001 and the Female students (as % of total students) in Secondary vocational education in 2006?
Ensure brevity in your answer.  6.31. What is the difference between the Female students (as % of total students) of Tertiary education in 2001 and the Female students (as % of total students) of Secondary general education in 2006?
Provide a succinct answer. -3.66. What is the difference between the Female students (as % of total students) in Tertiary education in 2001 and the Female students (as % of total students) in Secondary vocational education in 2006?
Ensure brevity in your answer.  5. What is the difference between the Female students (as % of total students) of Secondary general education in 2001 and the Female students (as % of total students) of Secondary vocational education in 2006?
Your answer should be compact. 8.41. What is the difference between the Female students (as % of total students) in Primary education in 2002 and the Female students (as % of total students) in Tertiary education in 2003?
Offer a very short reply. 0.99. What is the difference between the Female students (as % of total students) in Primary education in 2002 and the Female students (as % of total students) in Secondary general education in 2003?
Make the answer very short. -2.32. What is the difference between the Female students (as % of total students) in Primary education in 2002 and the Female students (as % of total students) in Secondary vocational education in 2003?
Ensure brevity in your answer.  7.88. What is the difference between the Female students (as % of total students) in Tertiary education in 2002 and the Female students (as % of total students) in Secondary general education in 2003?
Offer a very short reply. -3.45. What is the difference between the Female students (as % of total students) in Tertiary education in 2002 and the Female students (as % of total students) in Secondary vocational education in 2003?
Keep it short and to the point. 6.75. What is the difference between the Female students (as % of total students) in Secondary general education in 2002 and the Female students (as % of total students) in Secondary vocational education in 2003?
Ensure brevity in your answer.  10.08. What is the difference between the Female students (as % of total students) in Primary education in 2002 and the Female students (as % of total students) in Tertiary education in 2004?
Your answer should be compact. 0.9. What is the difference between the Female students (as % of total students) in Primary education in 2002 and the Female students (as % of total students) in Secondary general education in 2004?
Give a very brief answer. -2.38. What is the difference between the Female students (as % of total students) in Primary education in 2002 and the Female students (as % of total students) in Secondary vocational education in 2004?
Offer a very short reply. 7.43. What is the difference between the Female students (as % of total students) in Tertiary education in 2002 and the Female students (as % of total students) in Secondary general education in 2004?
Your response must be concise. -3.51. What is the difference between the Female students (as % of total students) of Tertiary education in 2002 and the Female students (as % of total students) of Secondary vocational education in 2004?
Your response must be concise. 6.29. What is the difference between the Female students (as % of total students) of Secondary general education in 2002 and the Female students (as % of total students) of Secondary vocational education in 2004?
Your response must be concise. 9.62. What is the difference between the Female students (as % of total students) of Primary education in 2002 and the Female students (as % of total students) of Tertiary education in 2005?
Give a very brief answer. 0.67. What is the difference between the Female students (as % of total students) of Primary education in 2002 and the Female students (as % of total students) of Secondary general education in 2005?
Your answer should be compact. -2.44. What is the difference between the Female students (as % of total students) in Primary education in 2002 and the Female students (as % of total students) in Secondary vocational education in 2005?
Offer a very short reply. 6.4. What is the difference between the Female students (as % of total students) in Tertiary education in 2002 and the Female students (as % of total students) in Secondary general education in 2005?
Your answer should be compact. -3.57. What is the difference between the Female students (as % of total students) in Tertiary education in 2002 and the Female students (as % of total students) in Secondary vocational education in 2005?
Your response must be concise. 5.27. What is the difference between the Female students (as % of total students) in Secondary general education in 2002 and the Female students (as % of total students) in Secondary vocational education in 2005?
Make the answer very short. 8.6. What is the difference between the Female students (as % of total students) of Primary education in 2002 and the Female students (as % of total students) of Tertiary education in 2006?
Make the answer very short. 0.64. What is the difference between the Female students (as % of total students) of Primary education in 2002 and the Female students (as % of total students) of Secondary general education in 2006?
Give a very brief answer. -2.35. What is the difference between the Female students (as % of total students) of Primary education in 2002 and the Female students (as % of total students) of Secondary vocational education in 2006?
Provide a short and direct response. 6.31. What is the difference between the Female students (as % of total students) of Tertiary education in 2002 and the Female students (as % of total students) of Secondary general education in 2006?
Ensure brevity in your answer.  -3.48. What is the difference between the Female students (as % of total students) of Tertiary education in 2002 and the Female students (as % of total students) of Secondary vocational education in 2006?
Your response must be concise. 5.18. What is the difference between the Female students (as % of total students) of Secondary general education in 2002 and the Female students (as % of total students) of Secondary vocational education in 2006?
Your response must be concise. 8.51. What is the difference between the Female students (as % of total students) of Primary education in 2003 and the Female students (as % of total students) of Tertiary education in 2004?
Keep it short and to the point. 0.91. What is the difference between the Female students (as % of total students) in Primary education in 2003 and the Female students (as % of total students) in Secondary general education in 2004?
Your answer should be compact. -2.36. What is the difference between the Female students (as % of total students) in Primary education in 2003 and the Female students (as % of total students) in Secondary vocational education in 2004?
Ensure brevity in your answer.  7.44. What is the difference between the Female students (as % of total students) of Tertiary education in 2003 and the Female students (as % of total students) of Secondary general education in 2004?
Your response must be concise. -3.37. What is the difference between the Female students (as % of total students) of Tertiary education in 2003 and the Female students (as % of total students) of Secondary vocational education in 2004?
Offer a terse response. 6.43. What is the difference between the Female students (as % of total students) of Secondary general education in 2003 and the Female students (as % of total students) of Secondary vocational education in 2004?
Your answer should be very brief. 9.75. What is the difference between the Female students (as % of total students) of Primary education in 2003 and the Female students (as % of total students) of Tertiary education in 2005?
Provide a short and direct response. 0.69. What is the difference between the Female students (as % of total students) in Primary education in 2003 and the Female students (as % of total students) in Secondary general education in 2005?
Keep it short and to the point. -2.42. What is the difference between the Female students (as % of total students) of Primary education in 2003 and the Female students (as % of total students) of Secondary vocational education in 2005?
Provide a succinct answer. 6.42. What is the difference between the Female students (as % of total students) of Tertiary education in 2003 and the Female students (as % of total students) of Secondary general education in 2005?
Make the answer very short. -3.43. What is the difference between the Female students (as % of total students) in Tertiary education in 2003 and the Female students (as % of total students) in Secondary vocational education in 2005?
Make the answer very short. 5.41. What is the difference between the Female students (as % of total students) in Secondary general education in 2003 and the Female students (as % of total students) in Secondary vocational education in 2005?
Provide a succinct answer. 8.72. What is the difference between the Female students (as % of total students) in Primary education in 2003 and the Female students (as % of total students) in Tertiary education in 2006?
Offer a very short reply. 0.66. What is the difference between the Female students (as % of total students) in Primary education in 2003 and the Female students (as % of total students) in Secondary general education in 2006?
Provide a succinct answer. -2.34. What is the difference between the Female students (as % of total students) in Primary education in 2003 and the Female students (as % of total students) in Secondary vocational education in 2006?
Make the answer very short. 6.33. What is the difference between the Female students (as % of total students) in Tertiary education in 2003 and the Female students (as % of total students) in Secondary general education in 2006?
Offer a very short reply. -3.34. What is the difference between the Female students (as % of total students) in Tertiary education in 2003 and the Female students (as % of total students) in Secondary vocational education in 2006?
Your answer should be compact. 5.32. What is the difference between the Female students (as % of total students) in Secondary general education in 2003 and the Female students (as % of total students) in Secondary vocational education in 2006?
Give a very brief answer. 8.63. What is the difference between the Female students (as % of total students) in Primary education in 2004 and the Female students (as % of total students) in Tertiary education in 2005?
Offer a terse response. 0.6. What is the difference between the Female students (as % of total students) of Primary education in 2004 and the Female students (as % of total students) of Secondary general education in 2005?
Ensure brevity in your answer.  -2.51. What is the difference between the Female students (as % of total students) of Primary education in 2004 and the Female students (as % of total students) of Secondary vocational education in 2005?
Your answer should be very brief. 6.33. What is the difference between the Female students (as % of total students) of Tertiary education in 2004 and the Female students (as % of total students) of Secondary general education in 2005?
Ensure brevity in your answer.  -3.33. What is the difference between the Female students (as % of total students) of Tertiary education in 2004 and the Female students (as % of total students) of Secondary vocational education in 2005?
Provide a short and direct response. 5.51. What is the difference between the Female students (as % of total students) of Secondary general education in 2004 and the Female students (as % of total students) of Secondary vocational education in 2005?
Ensure brevity in your answer.  8.78. What is the difference between the Female students (as % of total students) of Primary education in 2004 and the Female students (as % of total students) of Tertiary education in 2006?
Your response must be concise. 0.57. What is the difference between the Female students (as % of total students) of Primary education in 2004 and the Female students (as % of total students) of Secondary general education in 2006?
Your answer should be compact. -2.43. What is the difference between the Female students (as % of total students) in Primary education in 2004 and the Female students (as % of total students) in Secondary vocational education in 2006?
Your answer should be compact. 6.23. What is the difference between the Female students (as % of total students) in Tertiary education in 2004 and the Female students (as % of total students) in Secondary general education in 2006?
Give a very brief answer. -3.25. What is the difference between the Female students (as % of total students) in Tertiary education in 2004 and the Female students (as % of total students) in Secondary vocational education in 2006?
Give a very brief answer. 5.42. What is the difference between the Female students (as % of total students) of Secondary general education in 2004 and the Female students (as % of total students) of Secondary vocational education in 2006?
Make the answer very short. 8.69. What is the difference between the Female students (as % of total students) of Primary education in 2005 and the Female students (as % of total students) of Tertiary education in 2006?
Offer a terse response. 0.59. What is the difference between the Female students (as % of total students) of Primary education in 2005 and the Female students (as % of total students) of Secondary general education in 2006?
Keep it short and to the point. -2.41. What is the difference between the Female students (as % of total students) in Primary education in 2005 and the Female students (as % of total students) in Secondary vocational education in 2006?
Your response must be concise. 6.25. What is the difference between the Female students (as % of total students) in Tertiary education in 2005 and the Female students (as % of total students) in Secondary general education in 2006?
Your answer should be compact. -3.02. What is the difference between the Female students (as % of total students) of Tertiary education in 2005 and the Female students (as % of total students) of Secondary vocational education in 2006?
Provide a short and direct response. 5.64. What is the difference between the Female students (as % of total students) of Secondary general education in 2005 and the Female students (as % of total students) of Secondary vocational education in 2006?
Your answer should be very brief. 8.75. What is the average Female students (as % of total students) in Primary education per year?
Provide a short and direct response. 48.59. What is the average Female students (as % of total students) of Tertiary education per year?
Your answer should be compact. 47.53. What is the average Female students (as % of total students) in Secondary general education per year?
Your answer should be compact. 50.82. What is the average Female students (as % of total students) of Secondary vocational education per year?
Ensure brevity in your answer.  40.61. In the year 1998, what is the difference between the Female students (as % of total students) of Primary education and Female students (as % of total students) of Tertiary education?
Your answer should be very brief. 1.35. In the year 1998, what is the difference between the Female students (as % of total students) of Primary education and Female students (as % of total students) of Secondary general education?
Your response must be concise. -2.02. In the year 1998, what is the difference between the Female students (as % of total students) in Primary education and Female students (as % of total students) in Secondary vocational education?
Offer a terse response. 8.62. In the year 1998, what is the difference between the Female students (as % of total students) in Tertiary education and Female students (as % of total students) in Secondary general education?
Your answer should be very brief. -3.37. In the year 1998, what is the difference between the Female students (as % of total students) in Tertiary education and Female students (as % of total students) in Secondary vocational education?
Provide a succinct answer. 7.26. In the year 1998, what is the difference between the Female students (as % of total students) of Secondary general education and Female students (as % of total students) of Secondary vocational education?
Your answer should be very brief. 10.63. In the year 1999, what is the difference between the Female students (as % of total students) in Primary education and Female students (as % of total students) in Tertiary education?
Keep it short and to the point. 1.4. In the year 1999, what is the difference between the Female students (as % of total students) in Primary education and Female students (as % of total students) in Secondary general education?
Your answer should be very brief. -2.03. In the year 1999, what is the difference between the Female students (as % of total students) of Primary education and Female students (as % of total students) of Secondary vocational education?
Keep it short and to the point. 9.04. In the year 1999, what is the difference between the Female students (as % of total students) in Tertiary education and Female students (as % of total students) in Secondary general education?
Provide a succinct answer. -3.43. In the year 1999, what is the difference between the Female students (as % of total students) in Tertiary education and Female students (as % of total students) in Secondary vocational education?
Ensure brevity in your answer.  7.63. In the year 1999, what is the difference between the Female students (as % of total students) in Secondary general education and Female students (as % of total students) in Secondary vocational education?
Offer a terse response. 11.07. In the year 2000, what is the difference between the Female students (as % of total students) of Primary education and Female students (as % of total students) of Tertiary education?
Provide a short and direct response. 1.32. In the year 2000, what is the difference between the Female students (as % of total students) of Primary education and Female students (as % of total students) of Secondary general education?
Keep it short and to the point. -2.02. In the year 2000, what is the difference between the Female students (as % of total students) of Primary education and Female students (as % of total students) of Secondary vocational education?
Ensure brevity in your answer.  8.84. In the year 2000, what is the difference between the Female students (as % of total students) of Tertiary education and Female students (as % of total students) of Secondary general education?
Keep it short and to the point. -3.34. In the year 2000, what is the difference between the Female students (as % of total students) in Tertiary education and Female students (as % of total students) in Secondary vocational education?
Your answer should be compact. 7.52. In the year 2000, what is the difference between the Female students (as % of total students) in Secondary general education and Female students (as % of total students) in Secondary vocational education?
Your answer should be very brief. 10.85. In the year 2001, what is the difference between the Female students (as % of total students) in Primary education and Female students (as % of total students) in Tertiary education?
Make the answer very short. 1.31. In the year 2001, what is the difference between the Female students (as % of total students) of Primary education and Female students (as % of total students) of Secondary general education?
Your response must be concise. -2.1. In the year 2001, what is the difference between the Female students (as % of total students) in Primary education and Female students (as % of total students) in Secondary vocational education?
Provide a short and direct response. 9.07. In the year 2001, what is the difference between the Female students (as % of total students) of Tertiary education and Female students (as % of total students) of Secondary general education?
Give a very brief answer. -3.41. In the year 2001, what is the difference between the Female students (as % of total students) in Tertiary education and Female students (as % of total students) in Secondary vocational education?
Give a very brief answer. 7.76. In the year 2001, what is the difference between the Female students (as % of total students) of Secondary general education and Female students (as % of total students) of Secondary vocational education?
Make the answer very short. 11.17. In the year 2002, what is the difference between the Female students (as % of total students) of Primary education and Female students (as % of total students) of Tertiary education?
Make the answer very short. 1.13. In the year 2002, what is the difference between the Female students (as % of total students) in Primary education and Female students (as % of total students) in Secondary general education?
Keep it short and to the point. -2.2. In the year 2002, what is the difference between the Female students (as % of total students) in Primary education and Female students (as % of total students) in Secondary vocational education?
Provide a succinct answer. 8.41. In the year 2002, what is the difference between the Female students (as % of total students) of Tertiary education and Female students (as % of total students) of Secondary general education?
Make the answer very short. -3.33. In the year 2002, what is the difference between the Female students (as % of total students) of Tertiary education and Female students (as % of total students) of Secondary vocational education?
Ensure brevity in your answer.  7.28. In the year 2002, what is the difference between the Female students (as % of total students) in Secondary general education and Female students (as % of total students) in Secondary vocational education?
Make the answer very short. 10.61. In the year 2003, what is the difference between the Female students (as % of total students) in Primary education and Female students (as % of total students) in Tertiary education?
Your response must be concise. 1.01. In the year 2003, what is the difference between the Female students (as % of total students) of Primary education and Female students (as % of total students) of Secondary general education?
Make the answer very short. -2.31. In the year 2003, what is the difference between the Female students (as % of total students) in Primary education and Female students (as % of total students) in Secondary vocational education?
Your answer should be very brief. 7.89. In the year 2003, what is the difference between the Female students (as % of total students) in Tertiary education and Female students (as % of total students) in Secondary general education?
Make the answer very short. -3.31. In the year 2003, what is the difference between the Female students (as % of total students) in Tertiary education and Female students (as % of total students) in Secondary vocational education?
Provide a succinct answer. 6.89. In the year 2003, what is the difference between the Female students (as % of total students) of Secondary general education and Female students (as % of total students) of Secondary vocational education?
Your answer should be very brief. 10.2. In the year 2004, what is the difference between the Female students (as % of total students) of Primary education and Female students (as % of total students) of Tertiary education?
Your answer should be compact. 0.82. In the year 2004, what is the difference between the Female students (as % of total students) in Primary education and Female students (as % of total students) in Secondary general education?
Your response must be concise. -2.46. In the year 2004, what is the difference between the Female students (as % of total students) in Primary education and Female students (as % of total students) in Secondary vocational education?
Your answer should be compact. 7.35. In the year 2004, what is the difference between the Female students (as % of total students) in Tertiary education and Female students (as % of total students) in Secondary general education?
Provide a short and direct response. -3.27. In the year 2004, what is the difference between the Female students (as % of total students) in Tertiary education and Female students (as % of total students) in Secondary vocational education?
Keep it short and to the point. 6.53. In the year 2004, what is the difference between the Female students (as % of total students) in Secondary general education and Female students (as % of total students) in Secondary vocational education?
Offer a terse response. 9.8. In the year 2005, what is the difference between the Female students (as % of total students) in Primary education and Female students (as % of total students) in Tertiary education?
Keep it short and to the point. 0.61. In the year 2005, what is the difference between the Female students (as % of total students) of Primary education and Female students (as % of total students) of Secondary general education?
Give a very brief answer. -2.5. In the year 2005, what is the difference between the Female students (as % of total students) of Primary education and Female students (as % of total students) of Secondary vocational education?
Give a very brief answer. 6.34. In the year 2005, what is the difference between the Female students (as % of total students) in Tertiary education and Female students (as % of total students) in Secondary general education?
Your response must be concise. -3.11. In the year 2005, what is the difference between the Female students (as % of total students) of Tertiary education and Female students (as % of total students) of Secondary vocational education?
Provide a short and direct response. 5.73. In the year 2005, what is the difference between the Female students (as % of total students) in Secondary general education and Female students (as % of total students) in Secondary vocational education?
Offer a very short reply. 8.84. In the year 2006, what is the difference between the Female students (as % of total students) in Primary education and Female students (as % of total students) in Tertiary education?
Your response must be concise. 0.56. In the year 2006, what is the difference between the Female students (as % of total students) in Primary education and Female students (as % of total students) in Secondary general education?
Make the answer very short. -2.43. In the year 2006, what is the difference between the Female students (as % of total students) in Primary education and Female students (as % of total students) in Secondary vocational education?
Give a very brief answer. 6.23. In the year 2006, what is the difference between the Female students (as % of total students) in Tertiary education and Female students (as % of total students) in Secondary general education?
Make the answer very short. -3. In the year 2006, what is the difference between the Female students (as % of total students) of Tertiary education and Female students (as % of total students) of Secondary vocational education?
Ensure brevity in your answer.  5.67. In the year 2006, what is the difference between the Female students (as % of total students) of Secondary general education and Female students (as % of total students) of Secondary vocational education?
Offer a very short reply. 8.66. What is the ratio of the Female students (as % of total students) in Tertiary education in 1998 to that in 1999?
Your answer should be very brief. 1. What is the ratio of the Female students (as % of total students) of Secondary general education in 1998 to that in 1999?
Offer a terse response. 1. What is the ratio of the Female students (as % of total students) of Secondary vocational education in 1998 to that in 1999?
Make the answer very short. 1.01. What is the ratio of the Female students (as % of total students) in Primary education in 1998 to that in 2000?
Your answer should be compact. 1. What is the ratio of the Female students (as % of total students) of Secondary general education in 1998 to that in 2000?
Offer a terse response. 1. What is the ratio of the Female students (as % of total students) of Tertiary education in 1998 to that in 2001?
Ensure brevity in your answer.  1. What is the ratio of the Female students (as % of total students) of Secondary general education in 1998 to that in 2001?
Provide a succinct answer. 1. What is the ratio of the Female students (as % of total students) of Secondary vocational education in 1998 to that in 2001?
Provide a short and direct response. 1.01. What is the ratio of the Female students (as % of total students) in Primary education in 1998 to that in 2002?
Your answer should be compact. 1. What is the ratio of the Female students (as % of total students) of Tertiary education in 1998 to that in 2002?
Offer a very short reply. 1. What is the ratio of the Female students (as % of total students) in Tertiary education in 1998 to that in 2003?
Provide a succinct answer. 0.99. What is the ratio of the Female students (as % of total students) of Secondary vocational education in 1998 to that in 2003?
Your response must be concise. 0.98. What is the ratio of the Female students (as % of total students) of Primary education in 1998 to that in 2004?
Provide a short and direct response. 1. What is the ratio of the Female students (as % of total students) in Tertiary education in 1998 to that in 2004?
Provide a succinct answer. 0.99. What is the ratio of the Female students (as % of total students) in Secondary general education in 1998 to that in 2004?
Provide a short and direct response. 0.99. What is the ratio of the Female students (as % of total students) in Secondary vocational education in 1998 to that in 2004?
Offer a very short reply. 0.97. What is the ratio of the Female students (as % of total students) in Tertiary education in 1998 to that in 2005?
Provide a short and direct response. 0.99. What is the ratio of the Female students (as % of total students) of Secondary vocational education in 1998 to that in 2005?
Make the answer very short. 0.95. What is the ratio of the Female students (as % of total students) in Tertiary education in 1998 to that in 2006?
Give a very brief answer. 0.98. What is the ratio of the Female students (as % of total students) of Secondary vocational education in 1998 to that in 2006?
Your response must be concise. 0.95. What is the ratio of the Female students (as % of total students) in Primary education in 1999 to that in 2000?
Your answer should be very brief. 1. What is the ratio of the Female students (as % of total students) of Secondary vocational education in 1999 to that in 2000?
Give a very brief answer. 0.99. What is the ratio of the Female students (as % of total students) of Primary education in 1999 to that in 2001?
Your answer should be very brief. 1. What is the ratio of the Female students (as % of total students) in Secondary general education in 1999 to that in 2001?
Keep it short and to the point. 1. What is the ratio of the Female students (as % of total students) in Tertiary education in 1999 to that in 2002?
Provide a short and direct response. 0.99. What is the ratio of the Female students (as % of total students) in Secondary general education in 1999 to that in 2002?
Ensure brevity in your answer.  1. What is the ratio of the Female students (as % of total students) in Secondary vocational education in 1999 to that in 2002?
Your response must be concise. 0.98. What is the ratio of the Female students (as % of total students) in Primary education in 1999 to that in 2003?
Your response must be concise. 1. What is the ratio of the Female students (as % of total students) in Tertiary education in 1999 to that in 2003?
Keep it short and to the point. 0.99. What is the ratio of the Female students (as % of total students) of Secondary general education in 1999 to that in 2003?
Give a very brief answer. 0.99. What is the ratio of the Female students (as % of total students) of Secondary vocational education in 1999 to that in 2003?
Provide a succinct answer. 0.97. What is the ratio of the Female students (as % of total students) in Tertiary education in 1999 to that in 2004?
Give a very brief answer. 0.99. What is the ratio of the Female students (as % of total students) of Secondary vocational education in 1999 to that in 2004?
Your answer should be compact. 0.96. What is the ratio of the Female students (as % of total students) in Primary education in 1999 to that in 2005?
Give a very brief answer. 1. What is the ratio of the Female students (as % of total students) of Tertiary education in 1999 to that in 2005?
Keep it short and to the point. 0.98. What is the ratio of the Female students (as % of total students) in Secondary vocational education in 1999 to that in 2005?
Your answer should be very brief. 0.94. What is the ratio of the Female students (as % of total students) of Tertiary education in 1999 to that in 2006?
Your answer should be very brief. 0.98. What is the ratio of the Female students (as % of total students) in Secondary general education in 1999 to that in 2006?
Your answer should be very brief. 0.99. What is the ratio of the Female students (as % of total students) of Secondary vocational education in 1999 to that in 2006?
Offer a very short reply. 0.93. What is the ratio of the Female students (as % of total students) in Secondary general education in 2000 to that in 2001?
Your response must be concise. 1. What is the ratio of the Female students (as % of total students) of Secondary vocational education in 2000 to that in 2001?
Your response must be concise. 1.01. What is the ratio of the Female students (as % of total students) of Primary education in 2000 to that in 2002?
Make the answer very short. 1. What is the ratio of the Female students (as % of total students) in Tertiary education in 2000 to that in 2003?
Offer a very short reply. 0.99. What is the ratio of the Female students (as % of total students) of Secondary vocational education in 2000 to that in 2003?
Your answer should be compact. 0.98. What is the ratio of the Female students (as % of total students) in Primary education in 2000 to that in 2004?
Make the answer very short. 1. What is the ratio of the Female students (as % of total students) of Secondary vocational education in 2000 to that in 2004?
Provide a succinct answer. 0.97. What is the ratio of the Female students (as % of total students) of Tertiary education in 2000 to that in 2005?
Offer a very short reply. 0.99. What is the ratio of the Female students (as % of total students) in Secondary vocational education in 2000 to that in 2005?
Provide a succinct answer. 0.94. What is the ratio of the Female students (as % of total students) in Tertiary education in 2000 to that in 2006?
Your response must be concise. 0.99. What is the ratio of the Female students (as % of total students) in Secondary general education in 2000 to that in 2006?
Offer a terse response. 0.99. What is the ratio of the Female students (as % of total students) of Secondary vocational education in 2000 to that in 2006?
Provide a succinct answer. 0.94. What is the ratio of the Female students (as % of total students) of Tertiary education in 2001 to that in 2002?
Give a very brief answer. 1. What is the ratio of the Female students (as % of total students) in Secondary vocational education in 2001 to that in 2002?
Make the answer very short. 0.98. What is the ratio of the Female students (as % of total students) in Tertiary education in 2001 to that in 2003?
Offer a very short reply. 0.99. What is the ratio of the Female students (as % of total students) in Secondary vocational education in 2001 to that in 2003?
Make the answer very short. 0.97. What is the ratio of the Female students (as % of total students) in Primary education in 2001 to that in 2004?
Keep it short and to the point. 1. What is the ratio of the Female students (as % of total students) of Tertiary education in 2001 to that in 2004?
Offer a terse response. 0.99. What is the ratio of the Female students (as % of total students) of Secondary general education in 2001 to that in 2004?
Your answer should be compact. 0.99. What is the ratio of the Female students (as % of total students) in Secondary vocational education in 2001 to that in 2004?
Offer a terse response. 0.96. What is the ratio of the Female students (as % of total students) in Tertiary education in 2001 to that in 2005?
Your answer should be very brief. 0.99. What is the ratio of the Female students (as % of total students) of Secondary general education in 2001 to that in 2005?
Keep it short and to the point. 0.99. What is the ratio of the Female students (as % of total students) in Secondary vocational education in 2001 to that in 2005?
Give a very brief answer. 0.94. What is the ratio of the Female students (as % of total students) of Primary education in 2001 to that in 2006?
Offer a terse response. 1. What is the ratio of the Female students (as % of total students) of Tertiary education in 2001 to that in 2006?
Make the answer very short. 0.99. What is the ratio of the Female students (as % of total students) in Secondary vocational education in 2001 to that in 2006?
Offer a very short reply. 0.93. What is the ratio of the Female students (as % of total students) of Secondary vocational education in 2002 to that in 2003?
Keep it short and to the point. 0.99. What is the ratio of the Female students (as % of total students) in Secondary general education in 2002 to that in 2004?
Your answer should be compact. 1. What is the ratio of the Female students (as % of total students) in Tertiary education in 2002 to that in 2005?
Provide a short and direct response. 0.99. What is the ratio of the Female students (as % of total students) in Tertiary education in 2002 to that in 2006?
Provide a short and direct response. 0.99. What is the ratio of the Female students (as % of total students) in Secondary vocational education in 2002 to that in 2006?
Provide a short and direct response. 0.95. What is the ratio of the Female students (as % of total students) of Secondary vocational education in 2003 to that in 2004?
Give a very brief answer. 0.99. What is the ratio of the Female students (as % of total students) of Primary education in 2003 to that in 2005?
Give a very brief answer. 1. What is the ratio of the Female students (as % of total students) in Secondary vocational education in 2003 to that in 2005?
Ensure brevity in your answer.  0.96. What is the ratio of the Female students (as % of total students) of Primary education in 2003 to that in 2006?
Offer a very short reply. 1. What is the ratio of the Female students (as % of total students) in Tertiary education in 2003 to that in 2006?
Offer a terse response. 0.99. What is the ratio of the Female students (as % of total students) of Secondary vocational education in 2003 to that in 2006?
Give a very brief answer. 0.96. What is the ratio of the Female students (as % of total students) of Secondary vocational education in 2004 to that in 2005?
Give a very brief answer. 0.98. What is the ratio of the Female students (as % of total students) of Tertiary education in 2004 to that in 2006?
Provide a short and direct response. 0.99. What is the ratio of the Female students (as % of total students) of Secondary vocational education in 2004 to that in 2006?
Provide a short and direct response. 0.97. What is the ratio of the Female students (as % of total students) of Secondary vocational education in 2005 to that in 2006?
Offer a terse response. 1. What is the difference between the highest and the second highest Female students (as % of total students) in Primary education?
Provide a succinct answer. 0.01. What is the difference between the highest and the second highest Female students (as % of total students) of Tertiary education?
Keep it short and to the point. 0.03. What is the difference between the highest and the second highest Female students (as % of total students) of Secondary general education?
Keep it short and to the point. 0.06. What is the difference between the highest and the second highest Female students (as % of total students) of Secondary vocational education?
Provide a succinct answer. 0.09. What is the difference between the highest and the lowest Female students (as % of total students) in Primary education?
Offer a very short reply. 0.09. What is the difference between the highest and the lowest Female students (as % of total students) in Tertiary education?
Keep it short and to the point. 0.8. What is the difference between the highest and the lowest Female students (as % of total students) of Secondary general education?
Your answer should be compact. 0.45. What is the difference between the highest and the lowest Female students (as % of total students) of Secondary vocational education?
Offer a terse response. 2.77. 